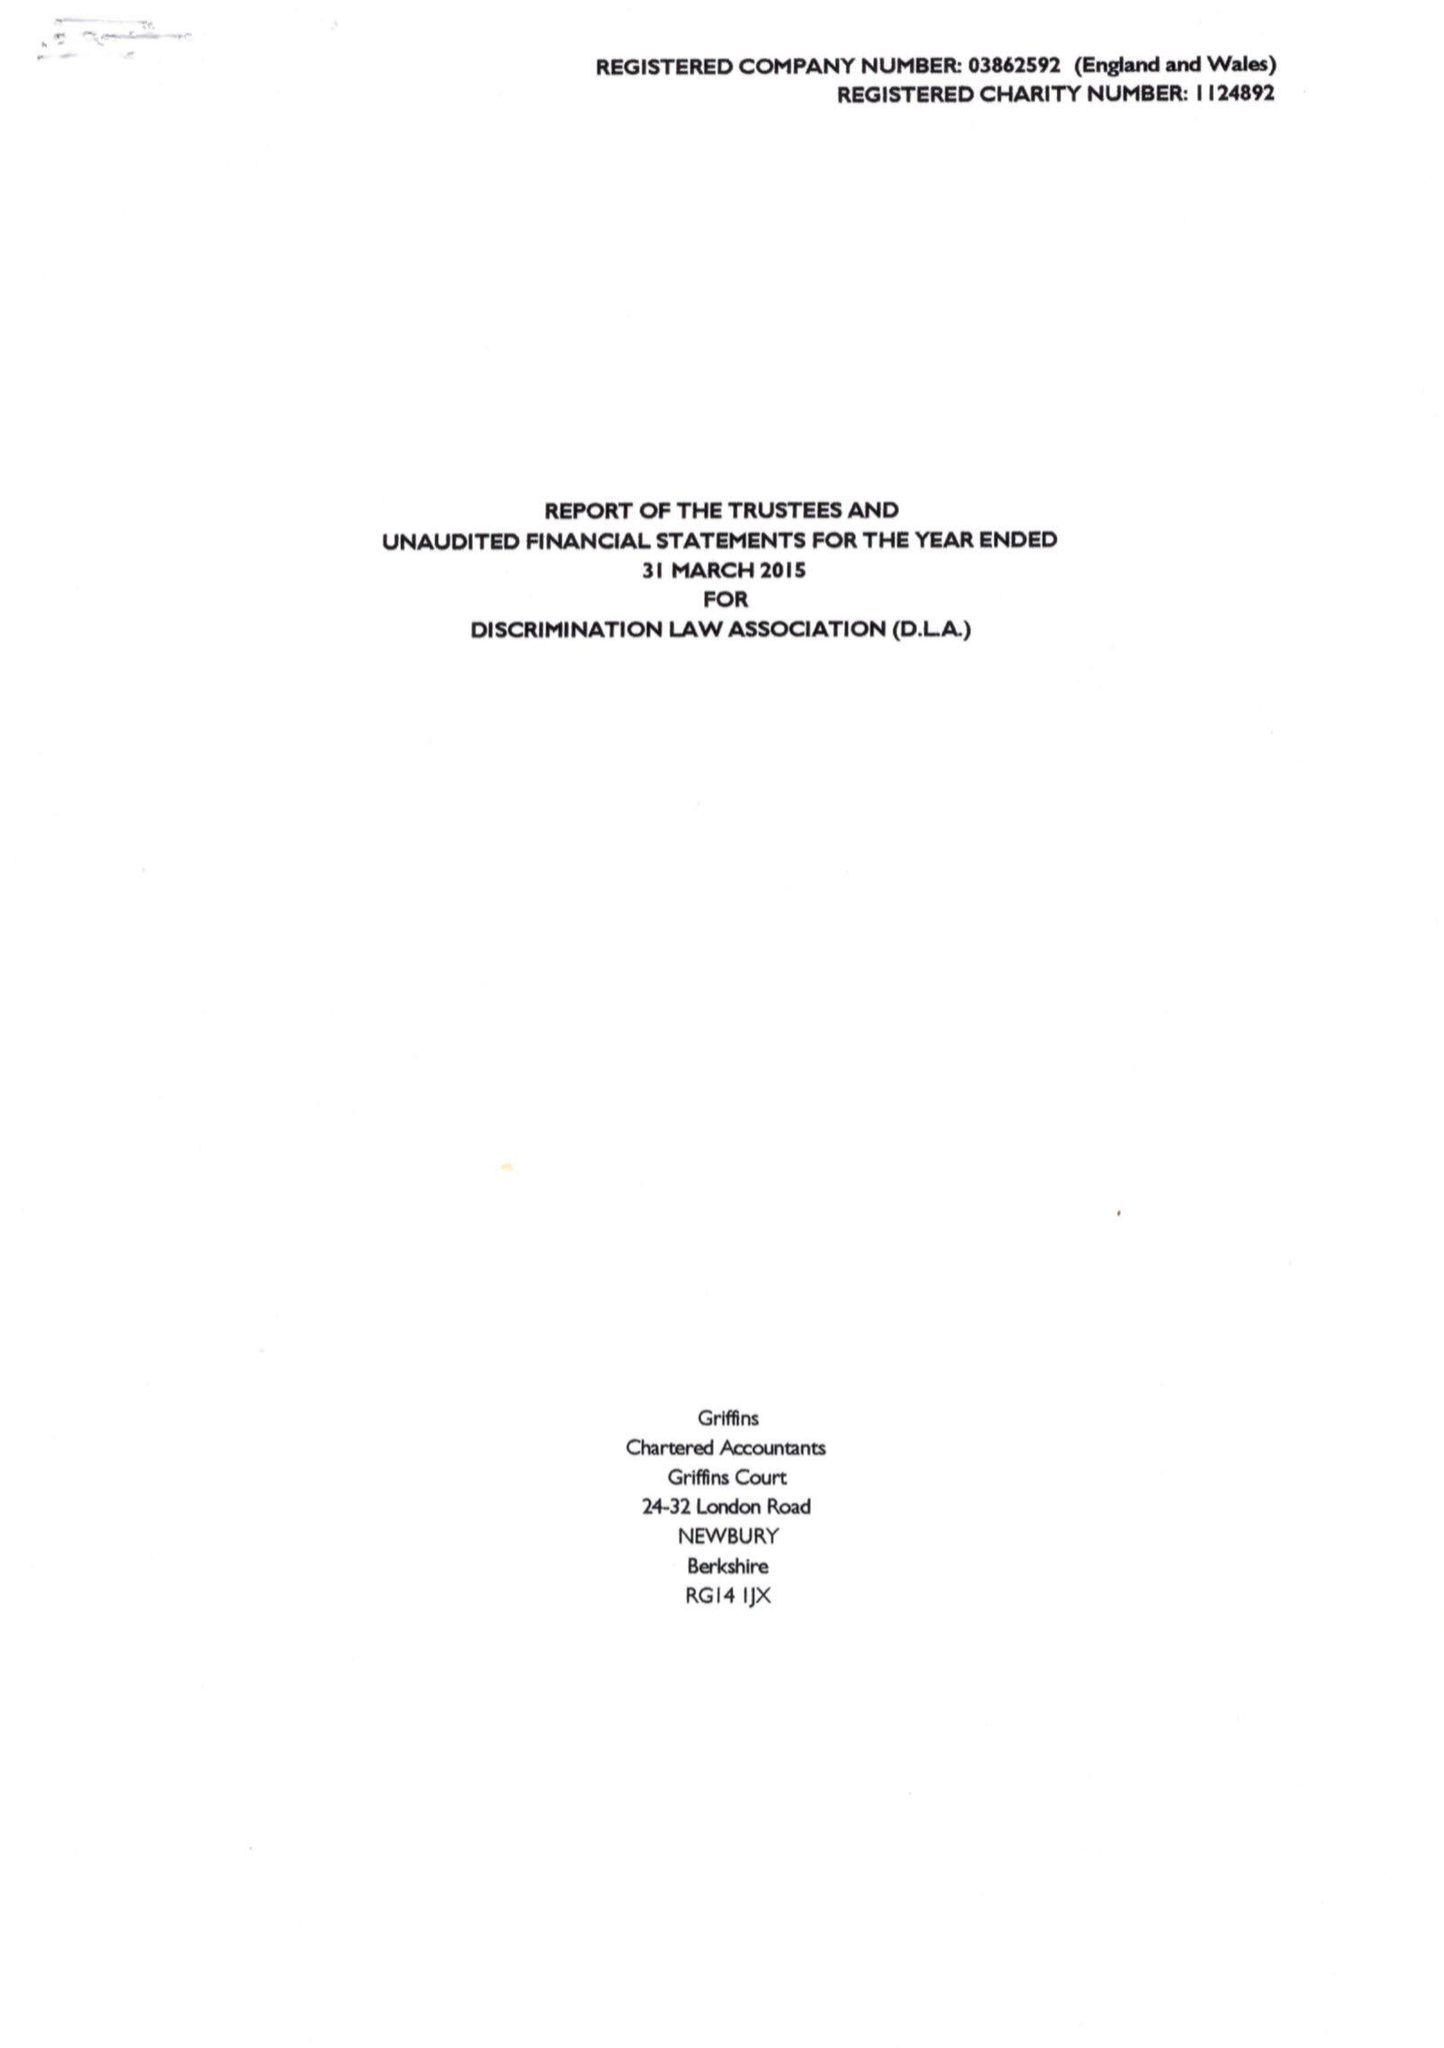What is the value for the address__street_line?
Answer the question using a single word or phrase. 33 CROMWELL AVENUE 